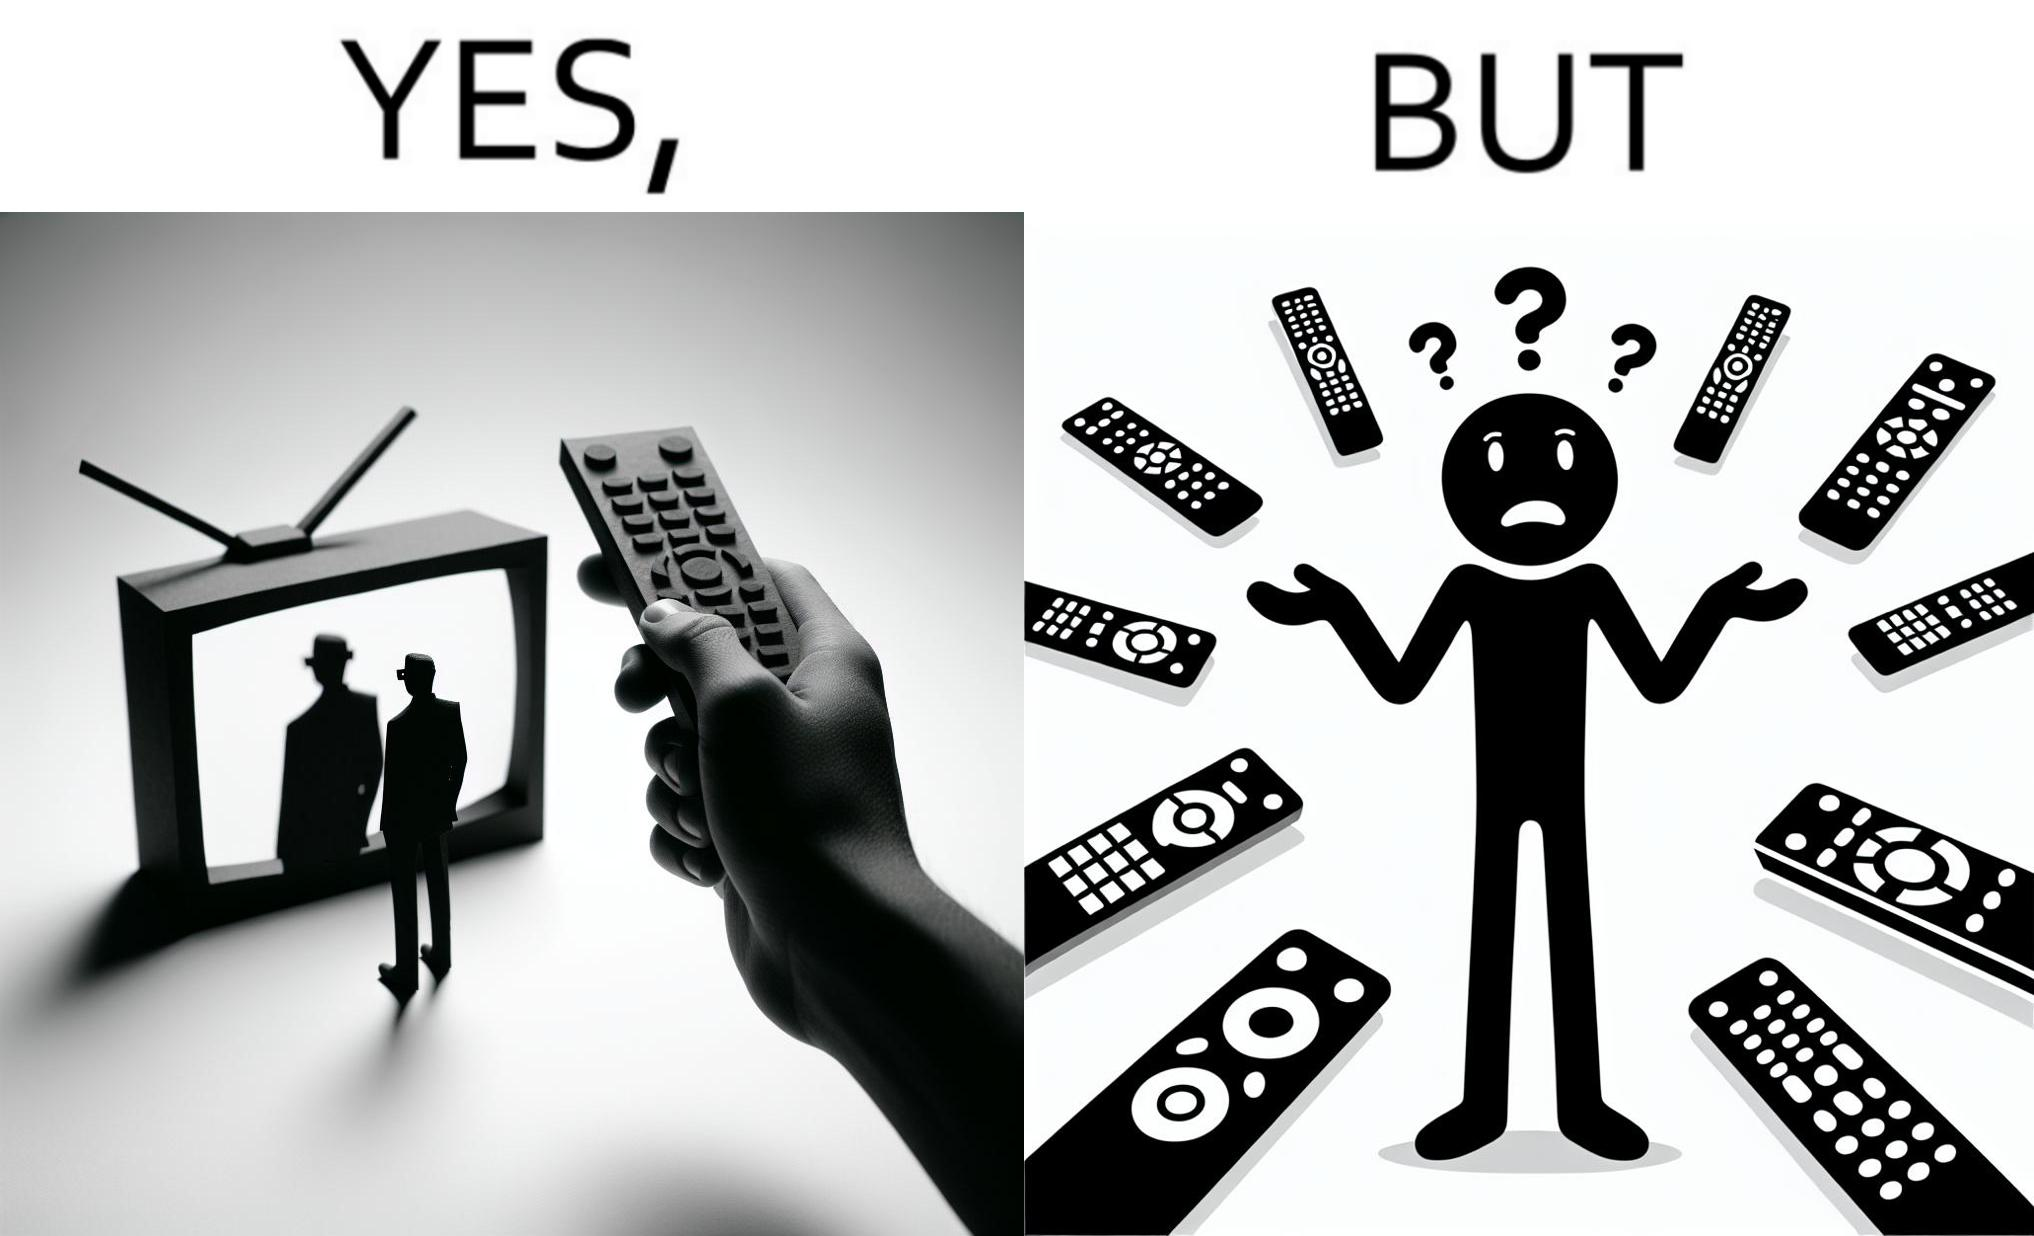What do you see in each half of this image? In the left part of the image: It is a remote being used to operate a TV In the right part of the image: It is an user confused between multiple remotes 